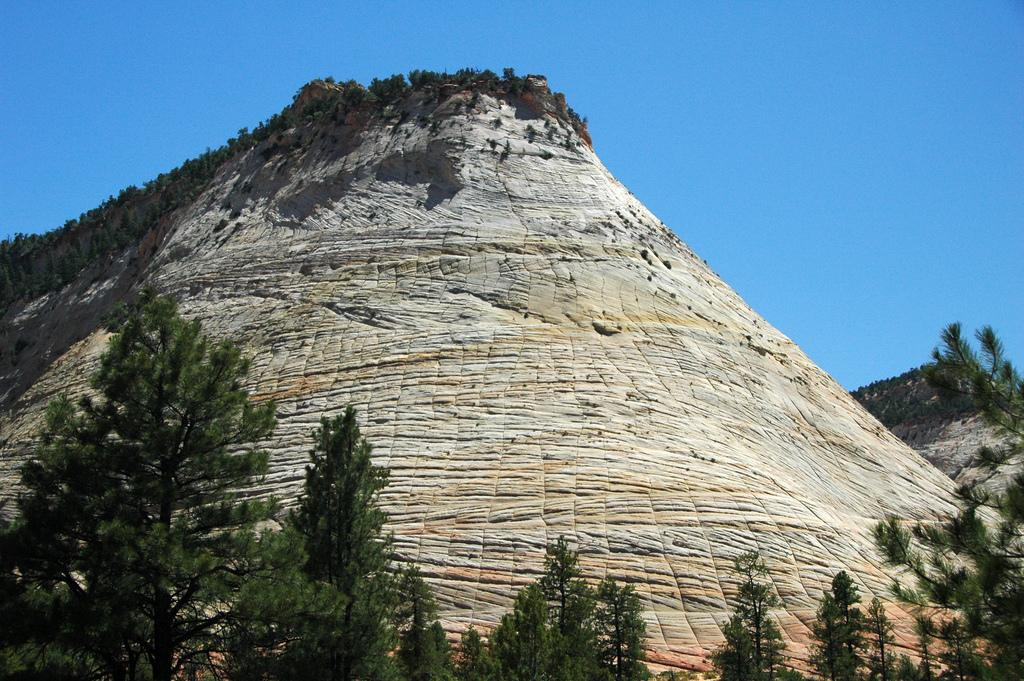What type of vegetation is at the bottom of the image? There are trees at the bottom of the image. What is located behind the trees at the bottom? There is a hill behind the trees. What can be seen at the top of the hill? There are trees at the top of the hill. What is visible at the top of the image? The sky is visible at the top of the image. What type of oatmeal is being served at the camp in the image? There is no camp or oatmeal present in the image; it features trees, a hill, and the sky. Is there an attack happening in the image? There is no indication of an attack or any conflict in the image. 